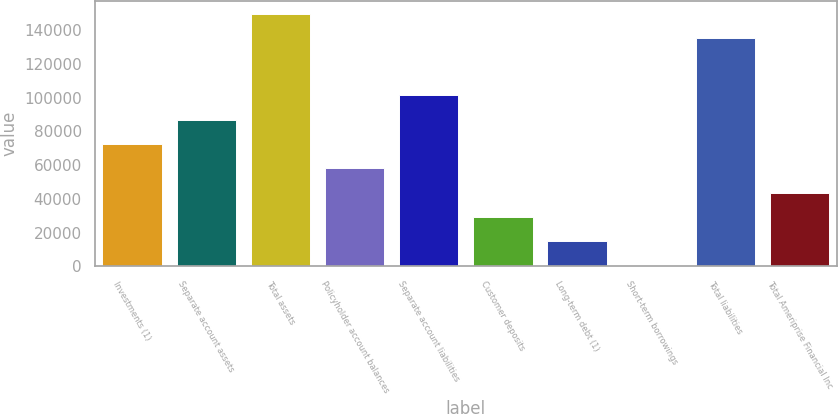Convert chart to OTSL. <chart><loc_0><loc_0><loc_500><loc_500><bar_chart><fcel>Investments (1)<fcel>Separate account assets<fcel>Total assets<fcel>Policyholder account balances<fcel>Separate account liabilities<fcel>Customer deposits<fcel>Long-term debt (1)<fcel>Short-term borrowings<fcel>Total liabilities<fcel>Total Ameriprise Financial Inc<nl><fcel>72532.5<fcel>86939<fcel>149766<fcel>58126<fcel>101346<fcel>29313<fcel>14906.5<fcel>500<fcel>135359<fcel>43719.5<nl></chart> 